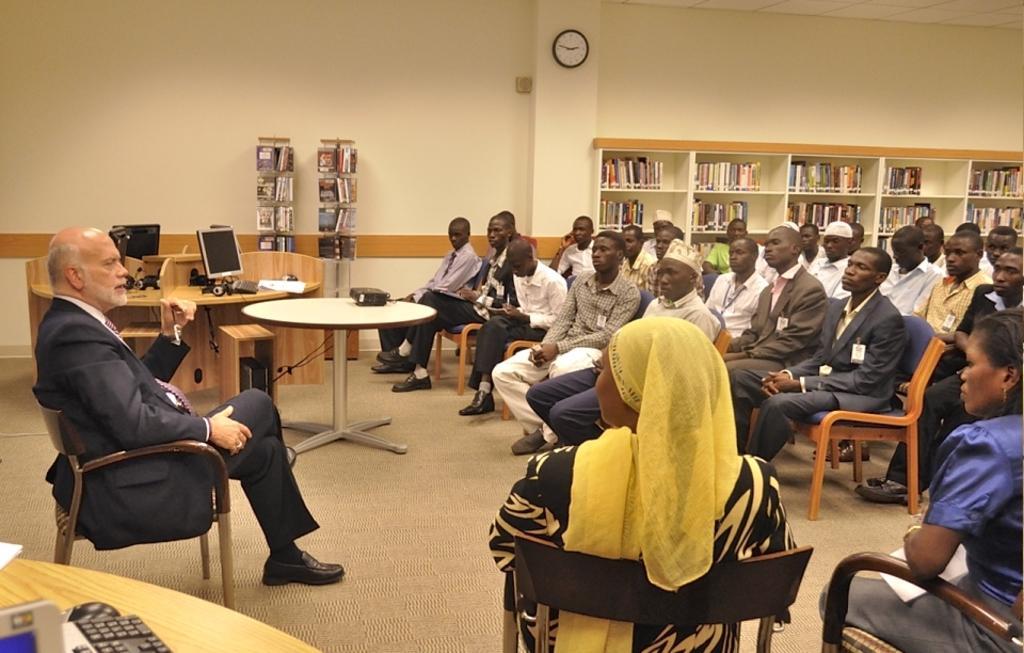Could you give a brief overview of what you see in this image? In the middle of the image there is a table, On the table there is a projector. Bottom right side of the image there is a few people sitting on a chair. Top right side of the image there is a wall. Bottom left side of the image there is a table, On the table there is a keyboard and mouse. Left side of the image there is a man sitting on a chair. Top left side of the image there are some monitors on the table. 